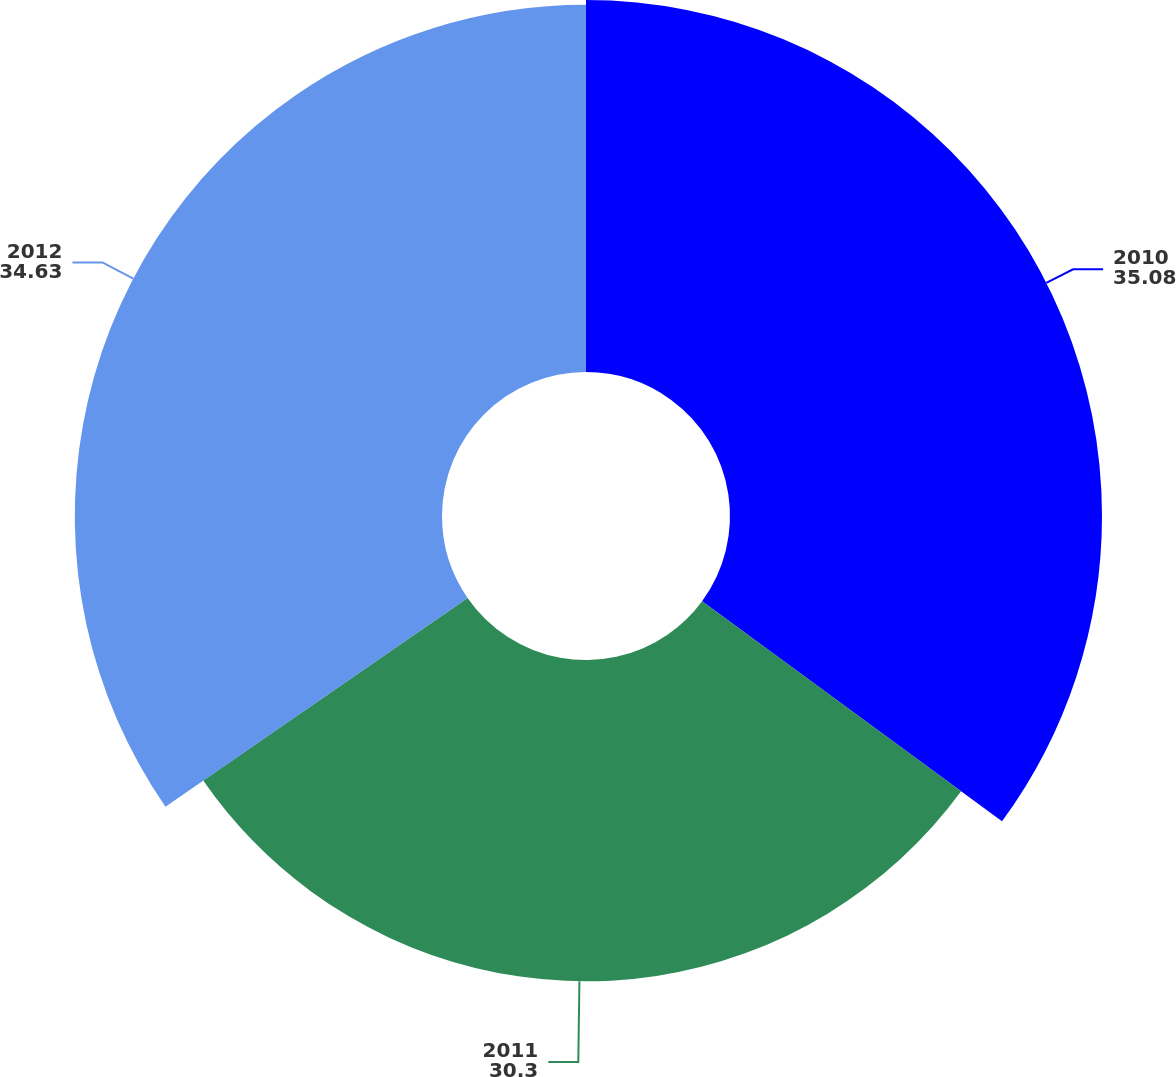Convert chart. <chart><loc_0><loc_0><loc_500><loc_500><pie_chart><fcel>2010<fcel>2011<fcel>2012<nl><fcel>35.08%<fcel>30.3%<fcel>34.63%<nl></chart> 